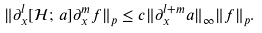Convert formula to latex. <formula><loc_0><loc_0><loc_500><loc_500>\| \partial _ { x } ^ { l } [ \mathcal { H } ; \, a ] \partial _ { x } ^ { m } f \| _ { p } \leq c \| \partial _ { x } ^ { l + m } a \| _ { \infty } \| f \| _ { p } .</formula> 